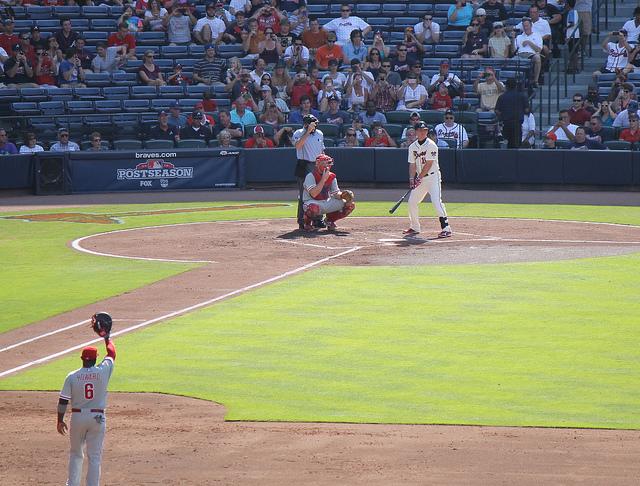Is there a sold-out crowd attending this ballgame?
Keep it brief. No. What is the person in white holding?
Be succinct. Bat. What number is the pitcher wearing?
Give a very brief answer. 6. What type of ball are they hitting?
Keep it brief. Baseball. What sport are they playing?
Give a very brief answer. Baseball. 